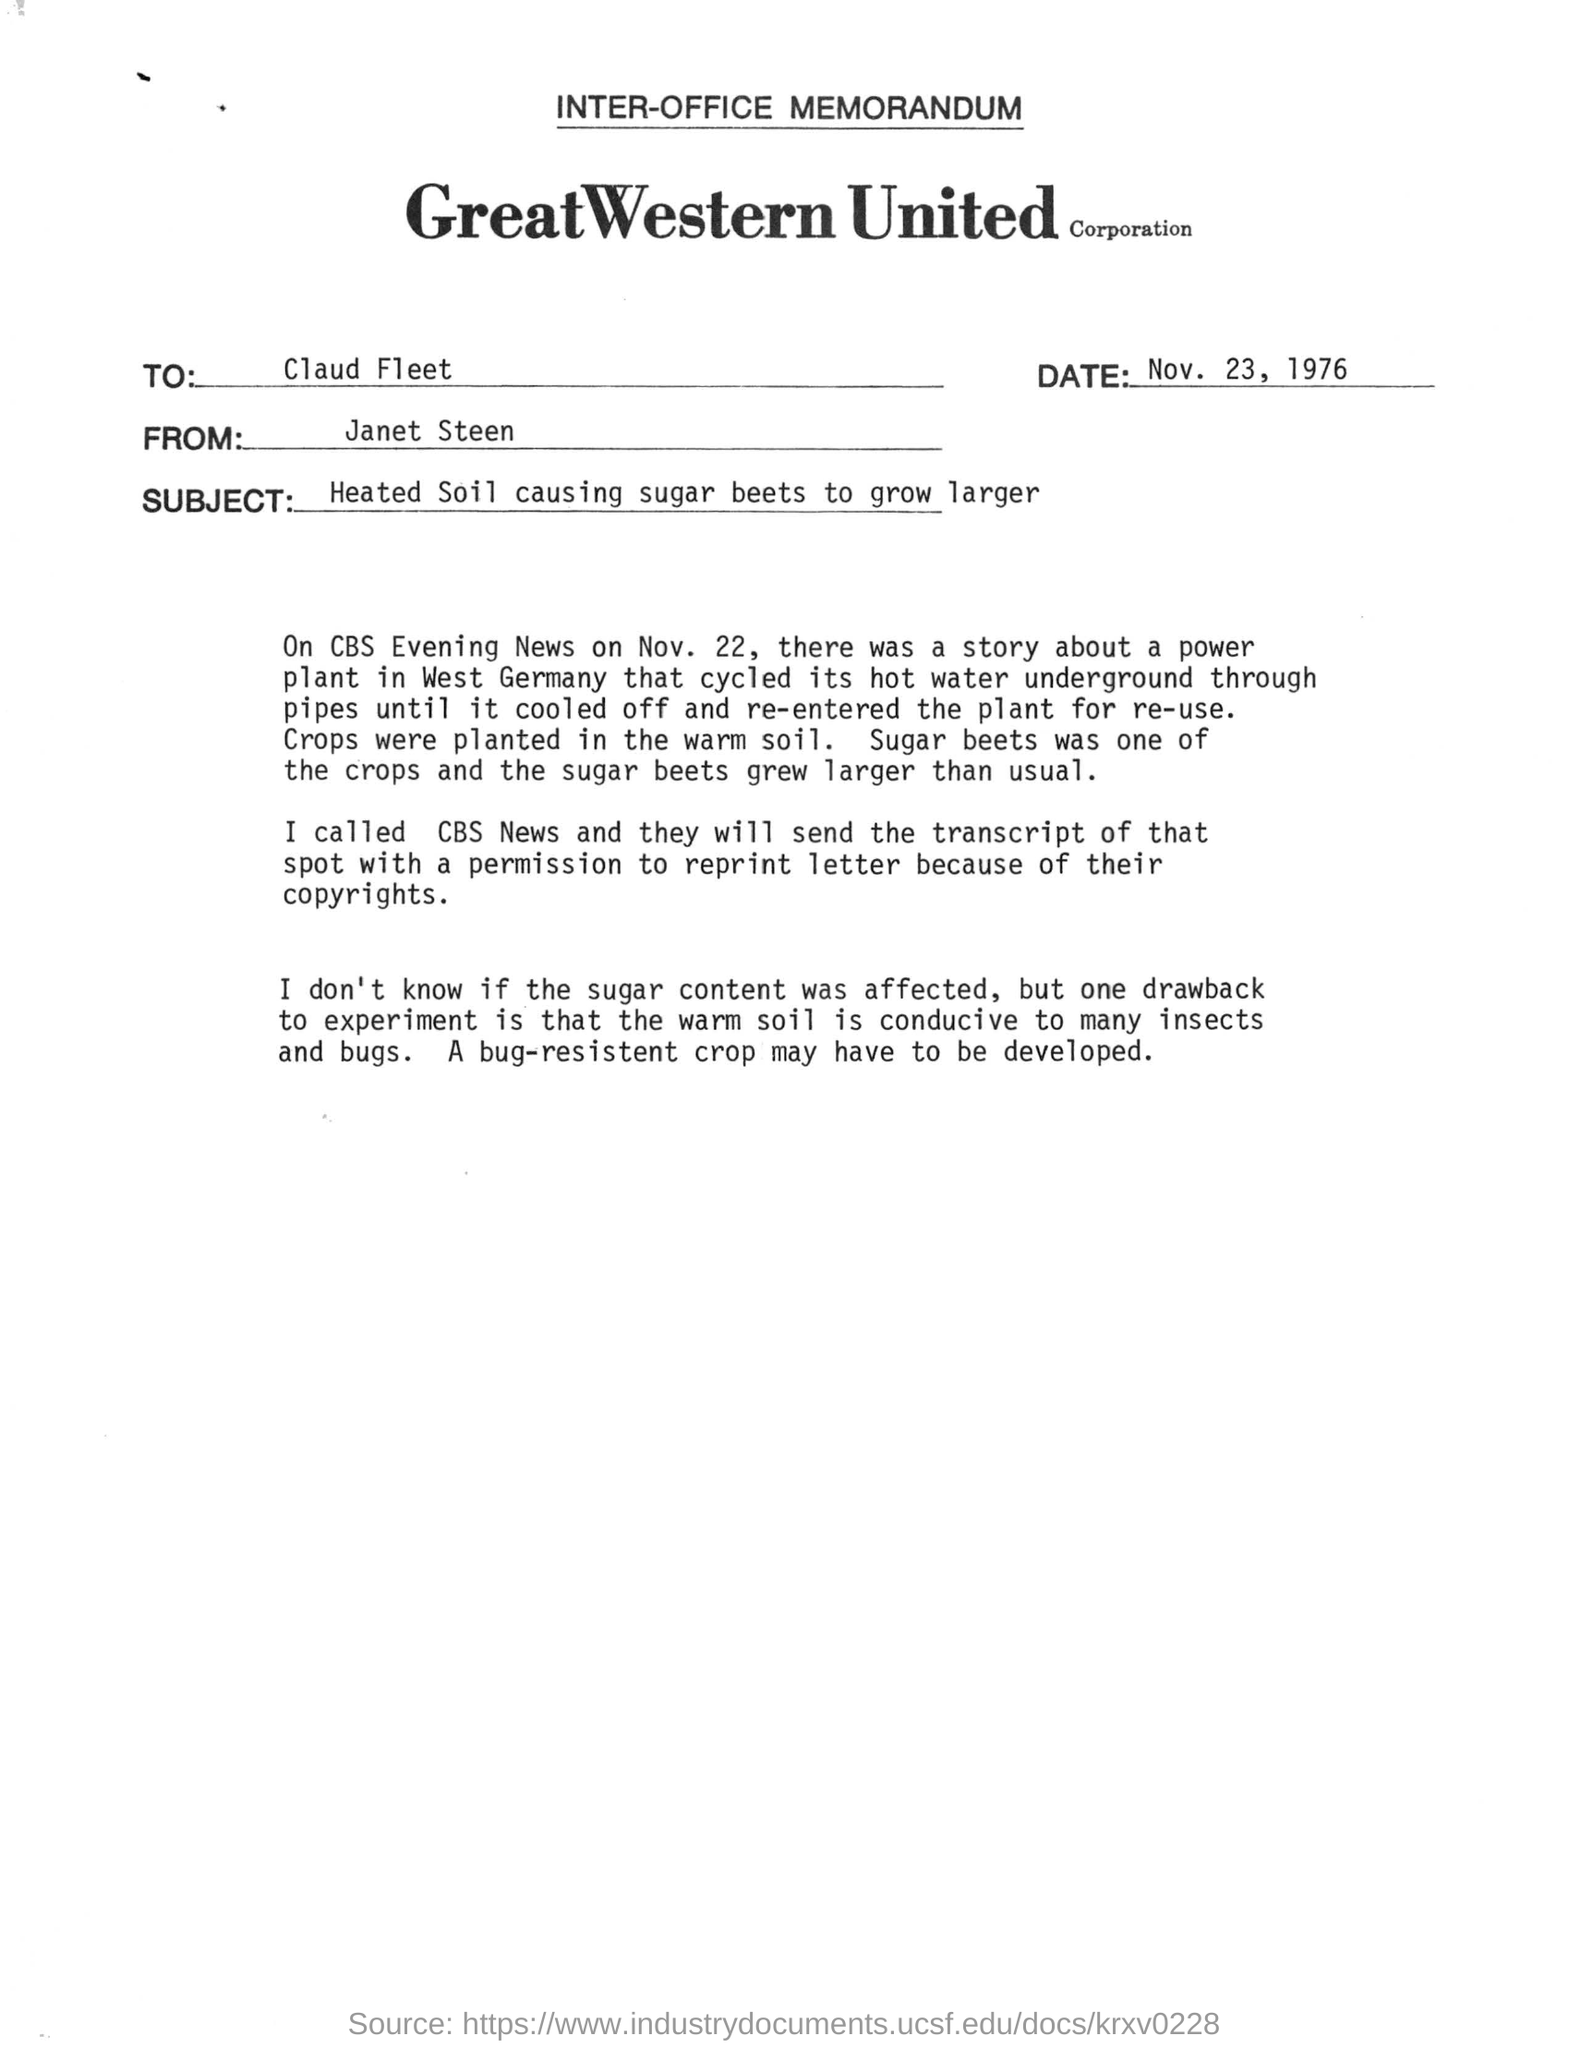To whom this letter is addressed?
Make the answer very short. Claud Fleet. What is the name of company?
Make the answer very short. GREATWESTERN UNITED CORPORATION. What is the subject of this document?
Keep it short and to the point. Heated Soil causing sugar beets to grow larger. 